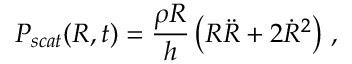Convert formula to latex. <formula><loc_0><loc_0><loc_500><loc_500>P _ { s c a t } ( R , t ) = \frac { \rho R } { h } \left ( R \ddot { R } + 2 \dot { R } ^ { 2 } \right ) \, ,</formula> 